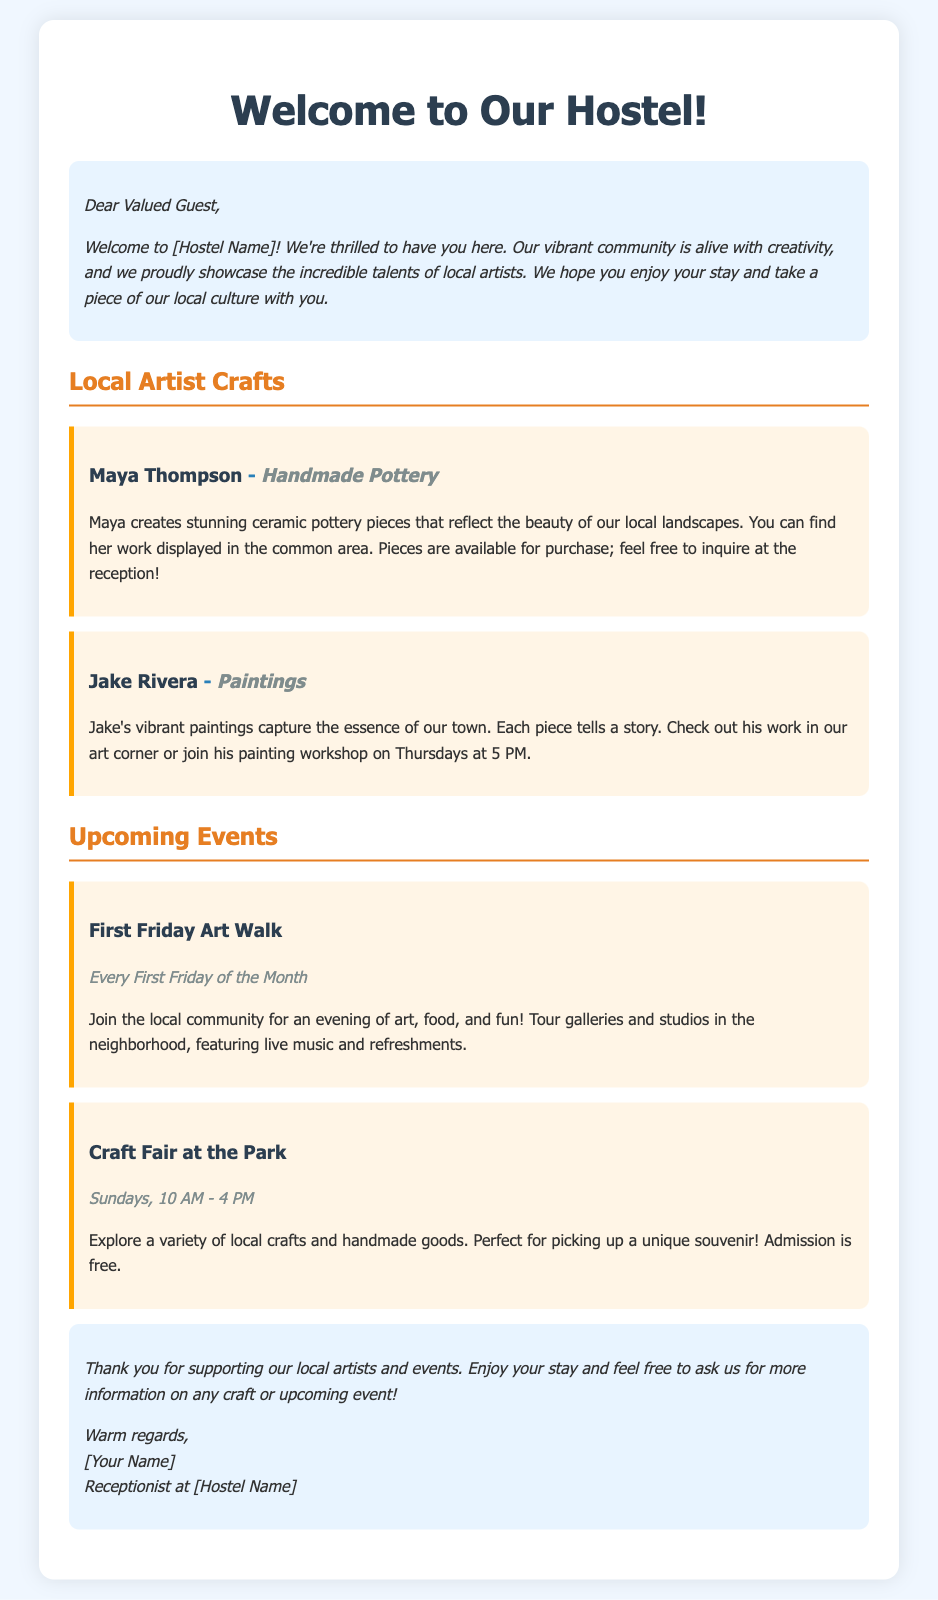What type of craft does Maya Thompson create? Maya Thompson is featured in the document as a local artist known for her stunning ceramic pottery pieces.
Answer: Handmade Pottery What day and time is Jake Rivera's painting workshop? The document states that Jake Rivera conducts his painting workshop on Thursdays at 5 PM.
Answer: Thursdays at 5 PM What is the admission cost for the Craft Fair at the Park? According to the document, admission to the Craft Fair at the Park is free.
Answer: Free When does the First Friday Art Walk occur? The document specifies that the First Friday Art Walk takes place every First Friday of the Month.
Answer: Every First Friday of the Month What is the main theme of Maya Thompson's pottery? The document describes Maya's pottery as reflecting the beauty of our local landscapes.
Answer: Local landscapes What can we find in the art corner of the hostel? The document mentions that Jake's vibrant paintings are displayed in the art corner, capturing the essence of the town.
Answer: Jake's paintings How long is the Craft Fair open on Sundays? The document states that the Craft Fair is open from 10 AM to 4 PM on Sundays.
Answer: 10 AM - 4 PM Who should guests ask for more information about local crafts? The closing section invites guests to ask the receptionist for more information on any craft or upcoming event.
Answer: Receptionist What type of events does the welcome package promote? The document promotes local artist crafts and community events.
Answer: Local artist crafts and events 